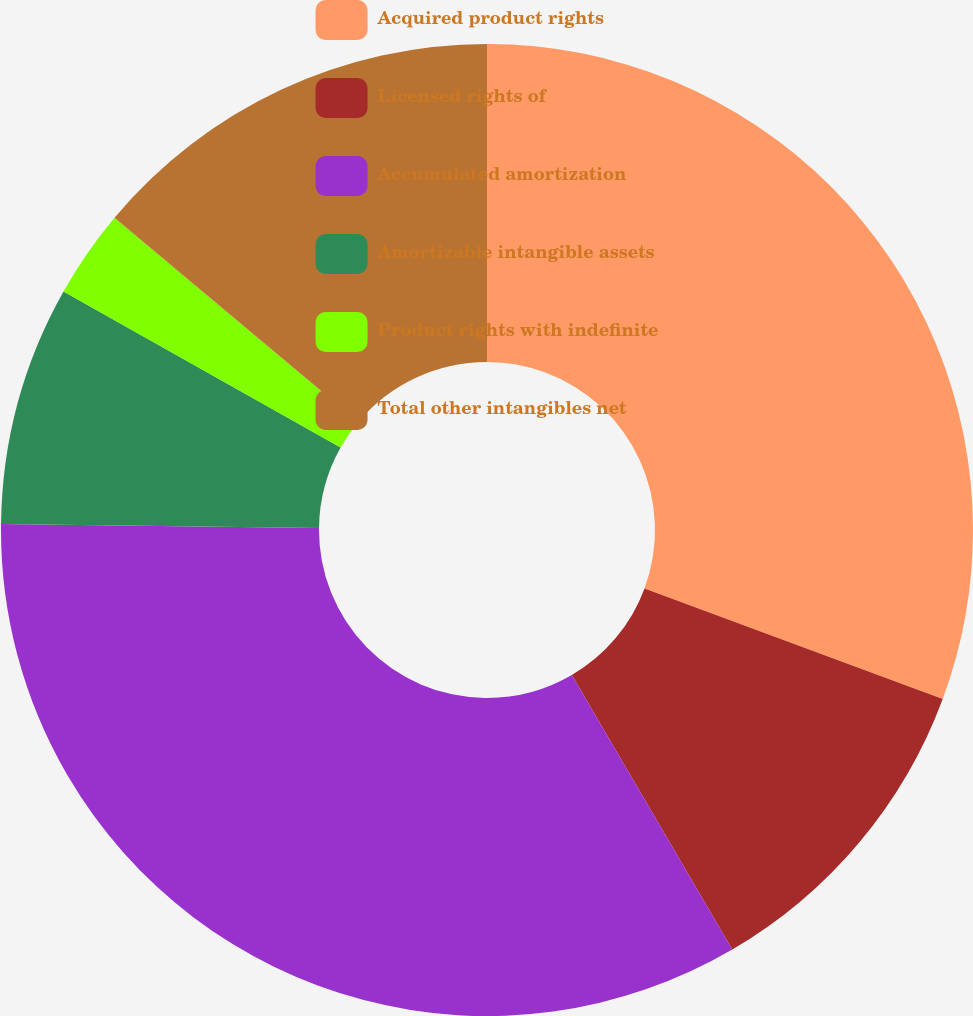Convert chart to OTSL. <chart><loc_0><loc_0><loc_500><loc_500><pie_chart><fcel>Acquired product rights<fcel>Licensed rights of<fcel>Accumulated amortization<fcel>Amortizable intangible assets<fcel>Product rights with indefinite<fcel>Total other intangibles net<nl><fcel>30.65%<fcel>10.93%<fcel>33.62%<fcel>7.96%<fcel>2.94%<fcel>13.9%<nl></chart> 